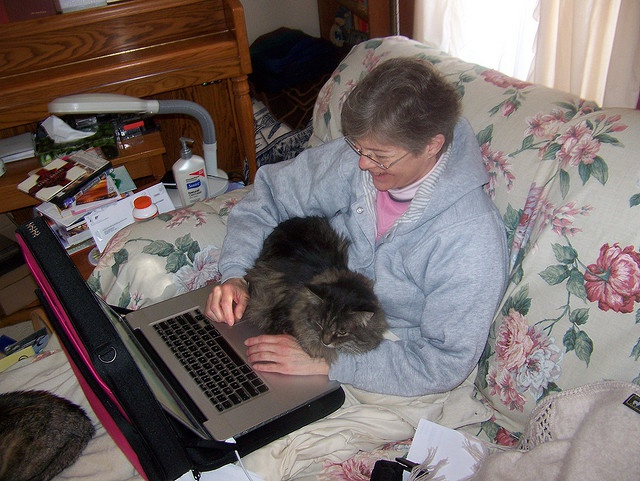Describe the objects in this image and their specific colors. I can see couch in maroon, darkgray, gray, and lightgray tones, people in maroon, darkgray, and gray tones, laptop in maroon, black, and gray tones, cat in maroon, black, and gray tones, and cat in maroon, black, and gray tones in this image. 